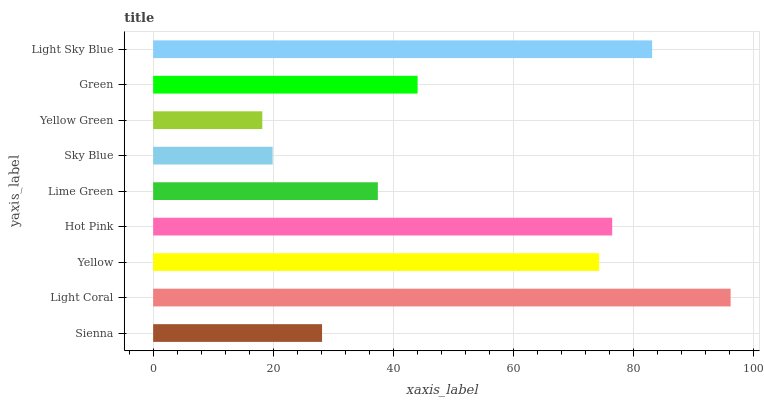Is Yellow Green the minimum?
Answer yes or no. Yes. Is Light Coral the maximum?
Answer yes or no. Yes. Is Yellow the minimum?
Answer yes or no. No. Is Yellow the maximum?
Answer yes or no. No. Is Light Coral greater than Yellow?
Answer yes or no. Yes. Is Yellow less than Light Coral?
Answer yes or no. Yes. Is Yellow greater than Light Coral?
Answer yes or no. No. Is Light Coral less than Yellow?
Answer yes or no. No. Is Green the high median?
Answer yes or no. Yes. Is Green the low median?
Answer yes or no. Yes. Is Light Sky Blue the high median?
Answer yes or no. No. Is Sky Blue the low median?
Answer yes or no. No. 